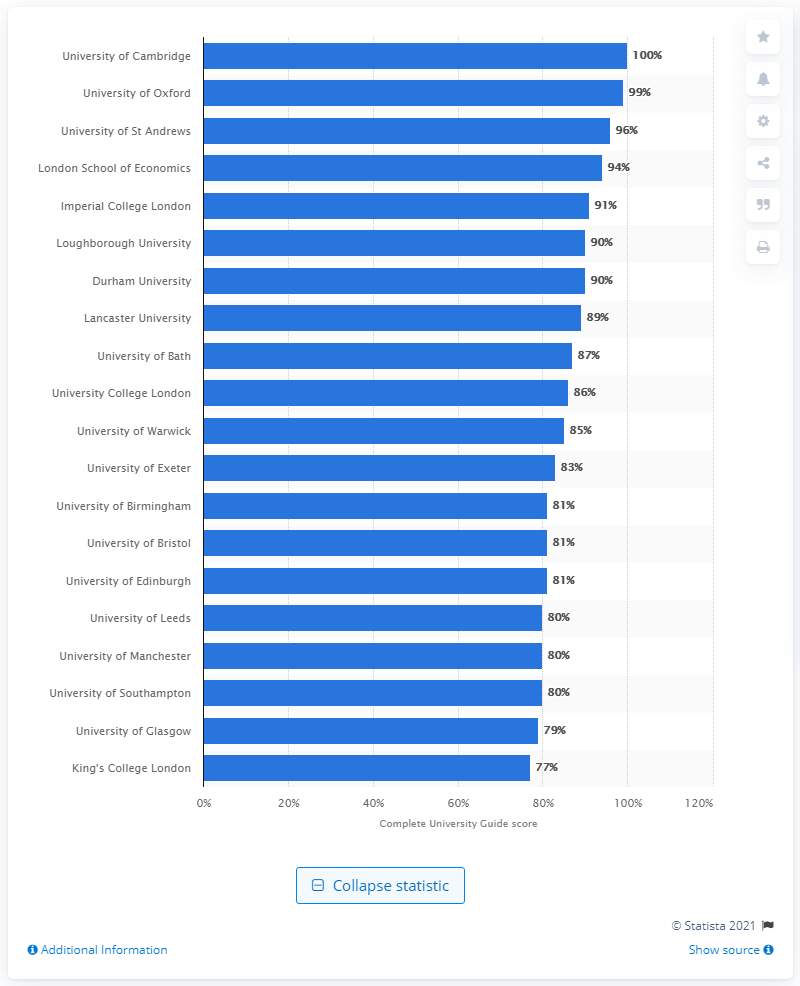Give some essential details in this illustration. The overall score of Cambridge University is 100. 